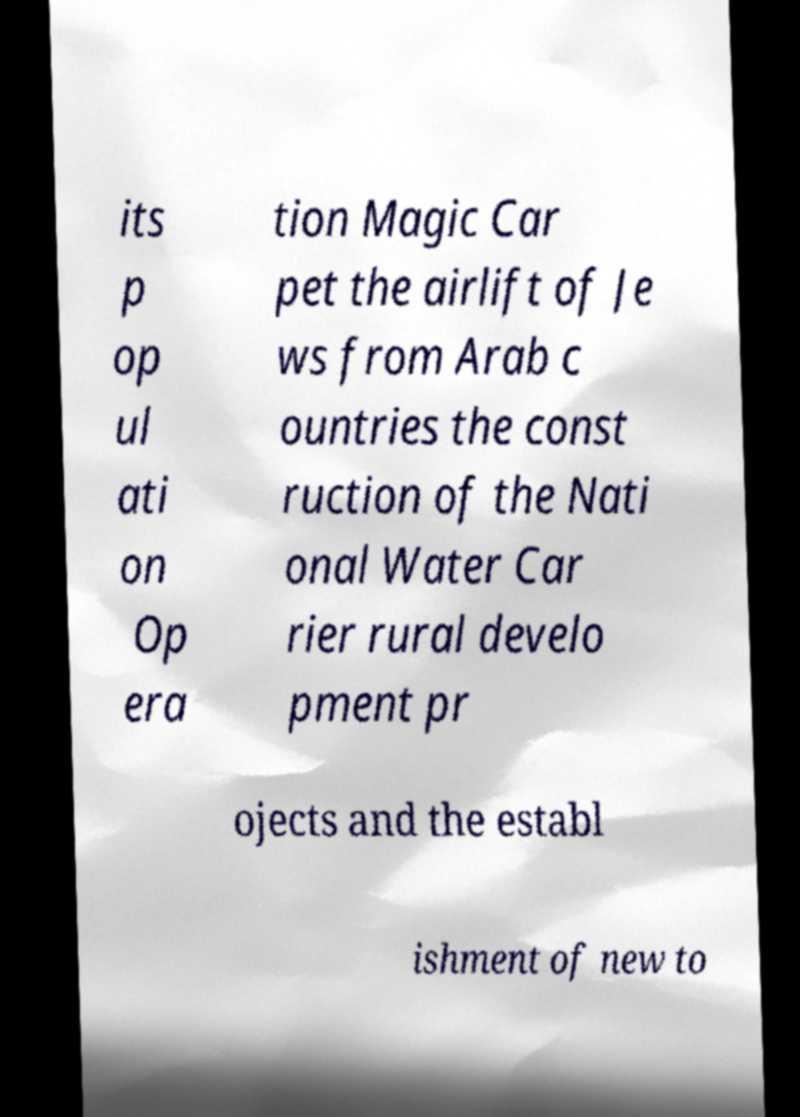Can you accurately transcribe the text from the provided image for me? its p op ul ati on Op era tion Magic Car pet the airlift of Je ws from Arab c ountries the const ruction of the Nati onal Water Car rier rural develo pment pr ojects and the establ ishment of new to 